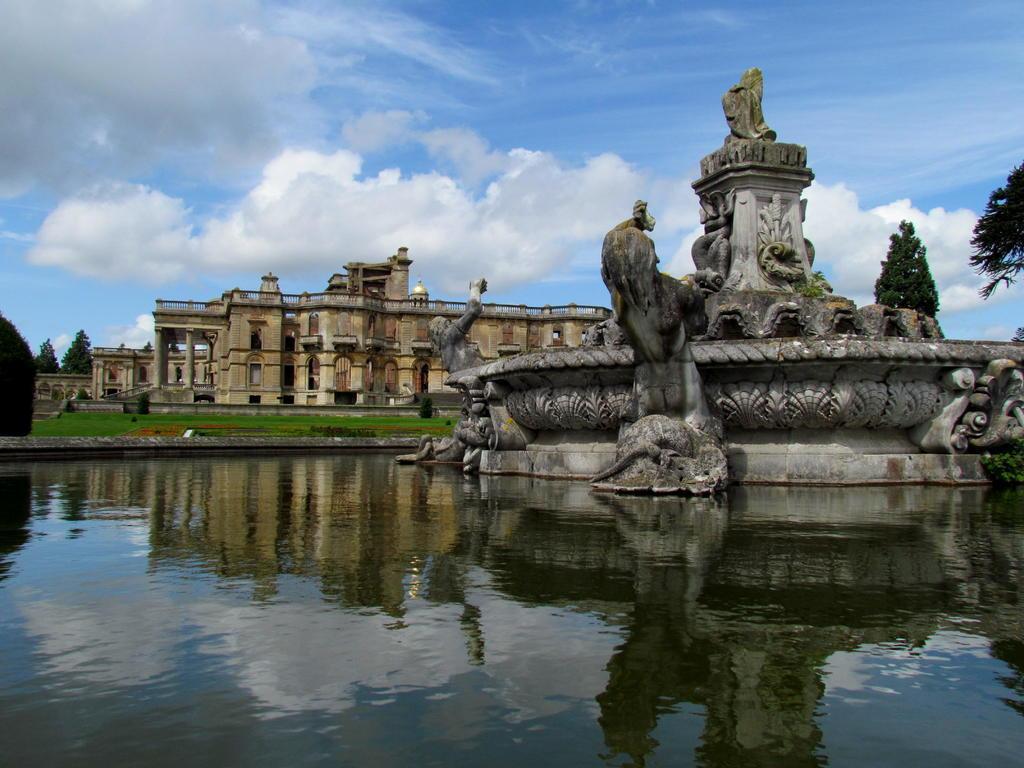In one or two sentences, can you explain what this image depicts? In this image I can see the water, a sculpture which is grey and black in color and in the background I can see few trees, and buildings which is brown and cream in color, some grass on the ground and the sky. 